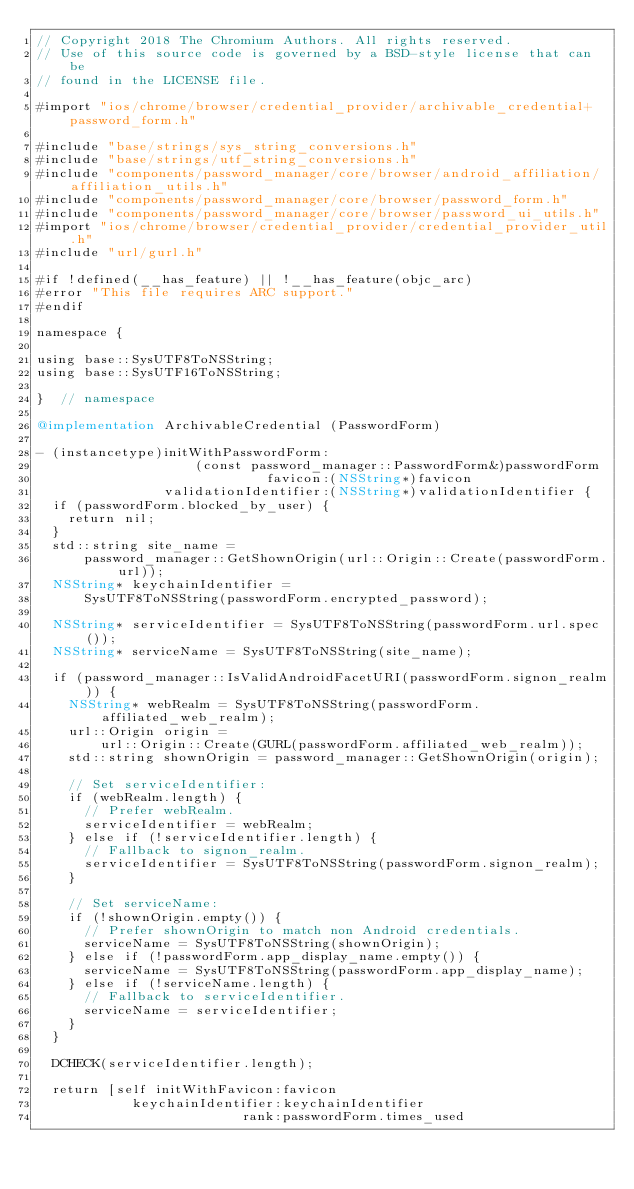<code> <loc_0><loc_0><loc_500><loc_500><_ObjectiveC_>// Copyright 2018 The Chromium Authors. All rights reserved.
// Use of this source code is governed by a BSD-style license that can be
// found in the LICENSE file.

#import "ios/chrome/browser/credential_provider/archivable_credential+password_form.h"

#include "base/strings/sys_string_conversions.h"
#include "base/strings/utf_string_conversions.h"
#include "components/password_manager/core/browser/android_affiliation/affiliation_utils.h"
#include "components/password_manager/core/browser/password_form.h"
#include "components/password_manager/core/browser/password_ui_utils.h"
#import "ios/chrome/browser/credential_provider/credential_provider_util.h"
#include "url/gurl.h"

#if !defined(__has_feature) || !__has_feature(objc_arc)
#error "This file requires ARC support."
#endif

namespace {

using base::SysUTF8ToNSString;
using base::SysUTF16ToNSString;

}  // namespace

@implementation ArchivableCredential (PasswordForm)

- (instancetype)initWithPasswordForm:
                    (const password_manager::PasswordForm&)passwordForm
                             favicon:(NSString*)favicon
                validationIdentifier:(NSString*)validationIdentifier {
  if (passwordForm.blocked_by_user) {
    return nil;
  }
  std::string site_name =
      password_manager::GetShownOrigin(url::Origin::Create(passwordForm.url));
  NSString* keychainIdentifier =
      SysUTF8ToNSString(passwordForm.encrypted_password);

  NSString* serviceIdentifier = SysUTF8ToNSString(passwordForm.url.spec());
  NSString* serviceName = SysUTF8ToNSString(site_name);

  if (password_manager::IsValidAndroidFacetURI(passwordForm.signon_realm)) {
    NSString* webRealm = SysUTF8ToNSString(passwordForm.affiliated_web_realm);
    url::Origin origin =
        url::Origin::Create(GURL(passwordForm.affiliated_web_realm));
    std::string shownOrigin = password_manager::GetShownOrigin(origin);

    // Set serviceIdentifier:
    if (webRealm.length) {
      // Prefer webRealm.
      serviceIdentifier = webRealm;
    } else if (!serviceIdentifier.length) {
      // Fallback to signon_realm.
      serviceIdentifier = SysUTF8ToNSString(passwordForm.signon_realm);
    }

    // Set serviceName:
    if (!shownOrigin.empty()) {
      // Prefer shownOrigin to match non Android credentials.
      serviceName = SysUTF8ToNSString(shownOrigin);
    } else if (!passwordForm.app_display_name.empty()) {
      serviceName = SysUTF8ToNSString(passwordForm.app_display_name);
    } else if (!serviceName.length) {
      // Fallback to serviceIdentifier.
      serviceName = serviceIdentifier;
    }
  }

  DCHECK(serviceIdentifier.length);

  return [self initWithFavicon:favicon
            keychainIdentifier:keychainIdentifier
                          rank:passwordForm.times_used</code> 